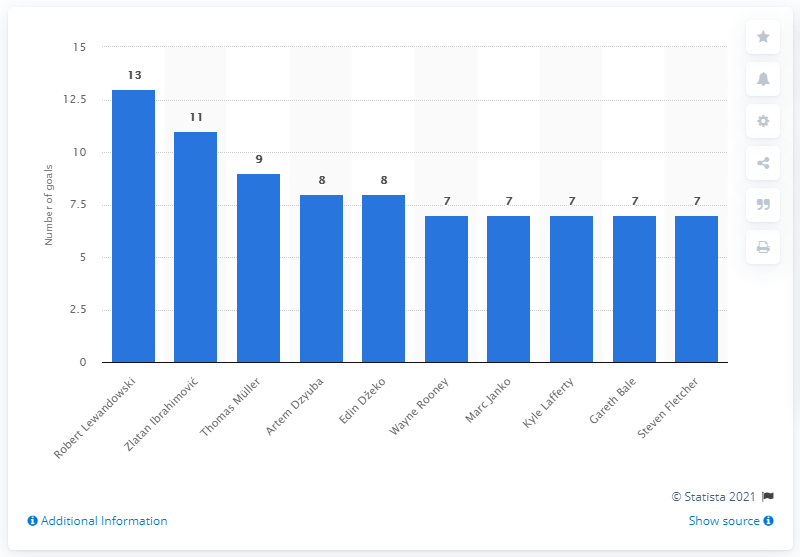Point out several critical features in this image. During the qualifying phase of the European Championship in 2016, Robert Lewandowski scored a total of 13 goals. 